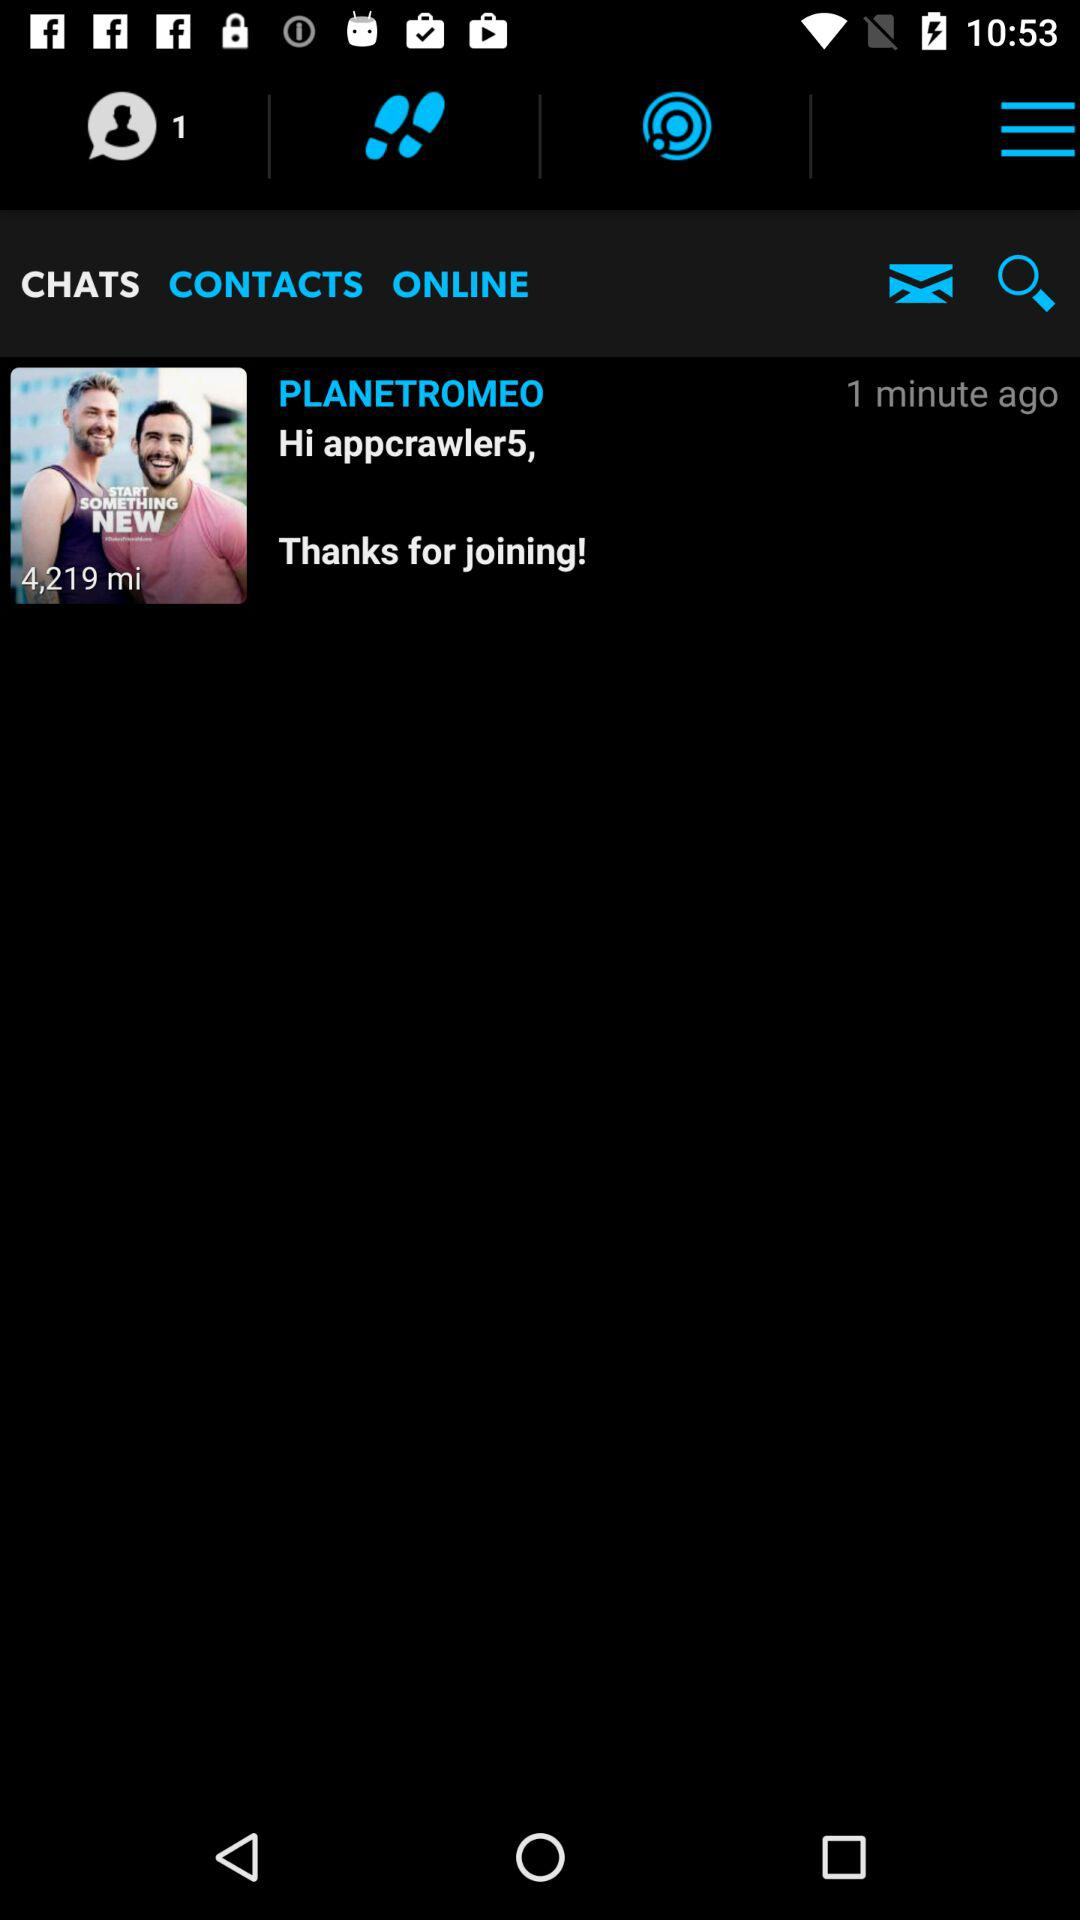How many minutes ago did someone join the chat?
Answer the question using a single word or phrase. 1 